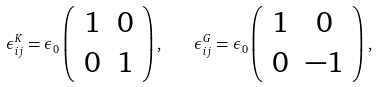Convert formula to latex. <formula><loc_0><loc_0><loc_500><loc_500>\epsilon _ { i j } ^ { K } = \epsilon _ { 0 } \left ( \begin{array} { c c } 1 & 0 \\ 0 & 1 \end{array} \right ) , \quad \epsilon _ { i j } ^ { G } = \epsilon _ { 0 } \left ( \begin{array} { c c } 1 & 0 \\ 0 & - 1 \end{array} \right ) ,</formula> 